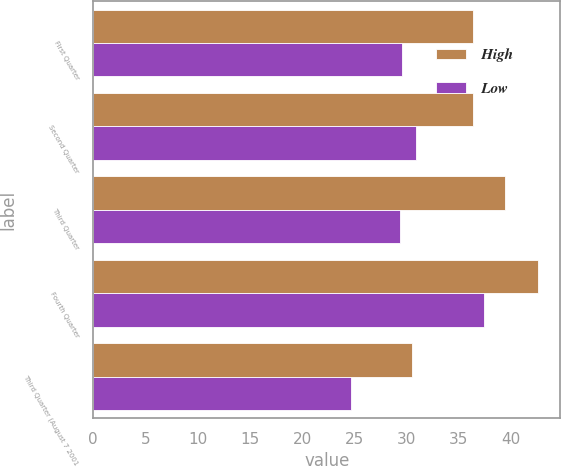Convert chart. <chart><loc_0><loc_0><loc_500><loc_500><stacked_bar_chart><ecel><fcel>First Quarter<fcel>Second Quarter<fcel>Third Quarter<fcel>Fourth Quarter<fcel>Third Quarter (August 7 2001<nl><fcel>High<fcel>36.36<fcel>36.34<fcel>39.46<fcel>42.6<fcel>30.5<nl><fcel>Low<fcel>29.55<fcel>30.9<fcel>29.37<fcel>37.46<fcel>24.7<nl></chart> 